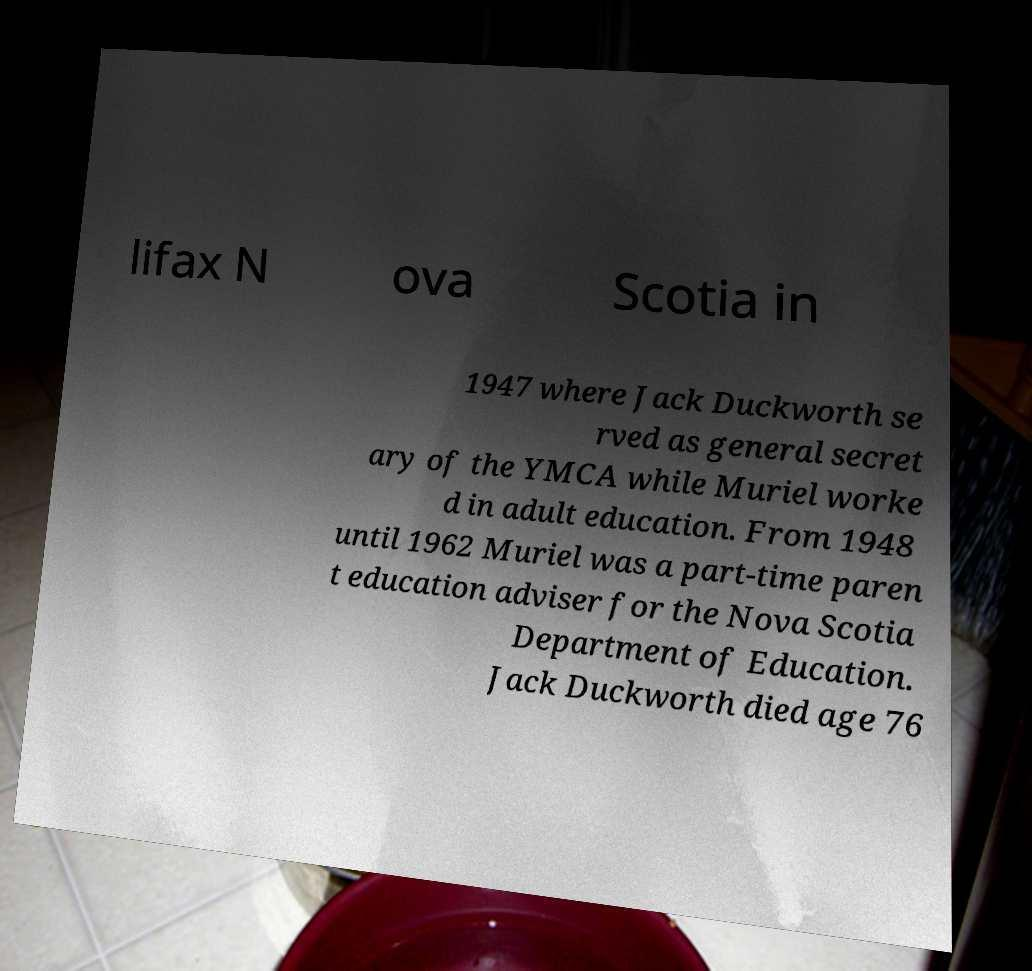Please identify and transcribe the text found in this image. lifax N ova Scotia in 1947 where Jack Duckworth se rved as general secret ary of the YMCA while Muriel worke d in adult education. From 1948 until 1962 Muriel was a part-time paren t education adviser for the Nova Scotia Department of Education. Jack Duckworth died age 76 